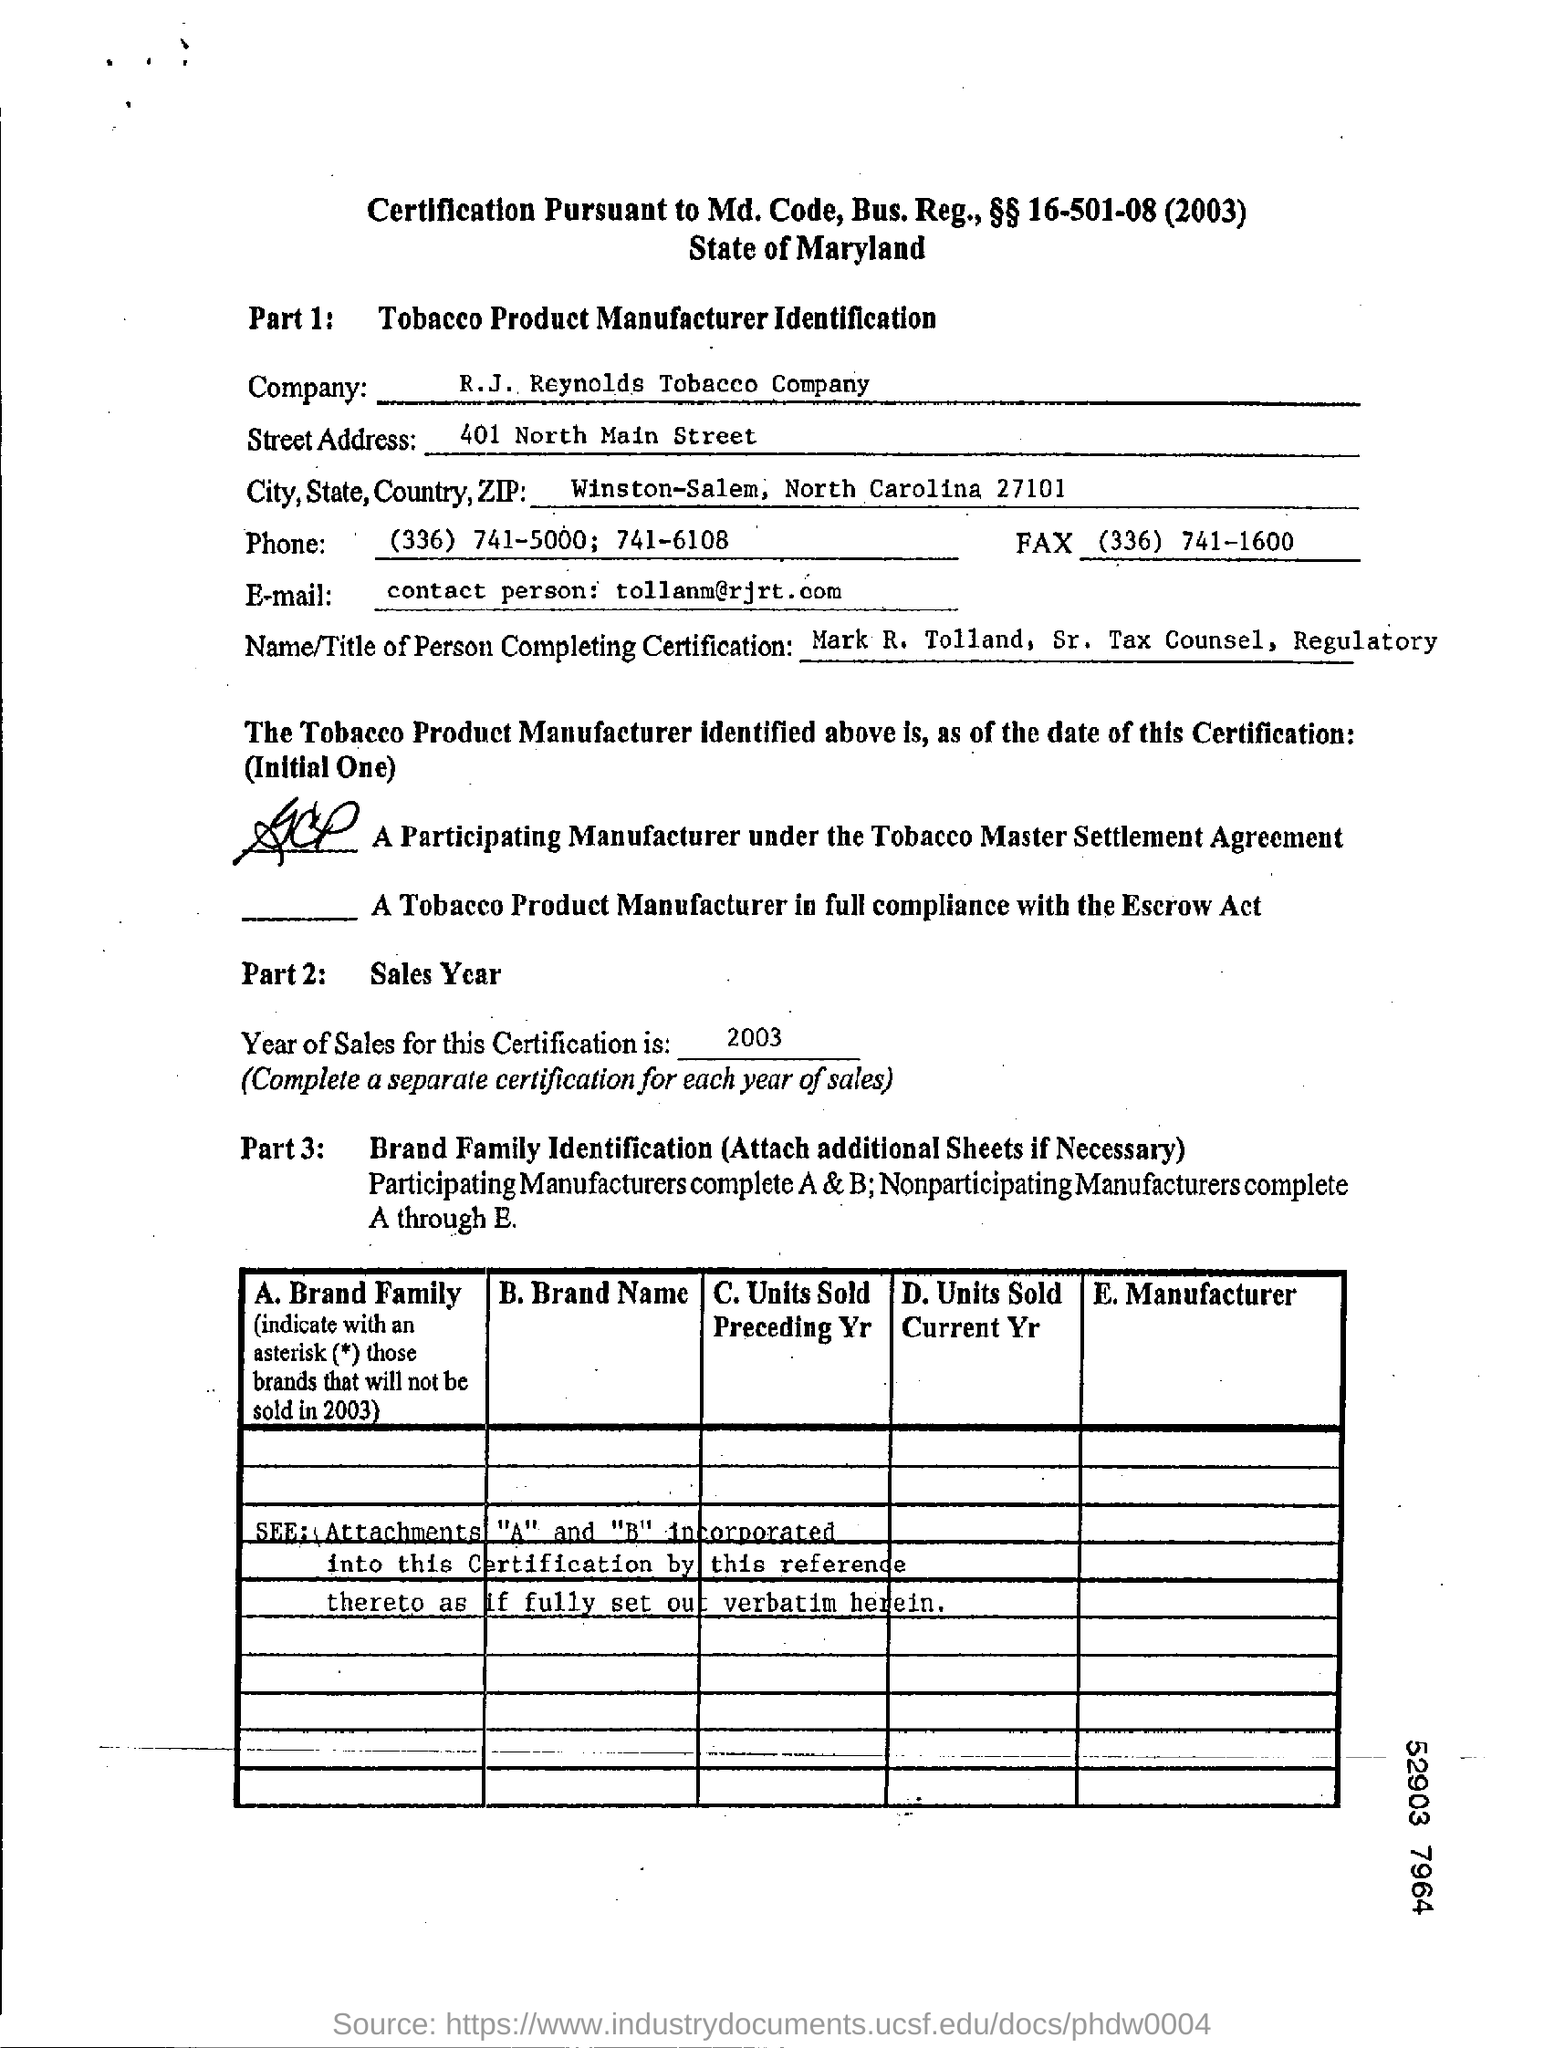What is the name of company
Ensure brevity in your answer.  R.J. Reynolds Tobacco company. What is the email id of r.j. reynolds tobacco company?
Give a very brief answer. Tollanm@rjrt.com. 